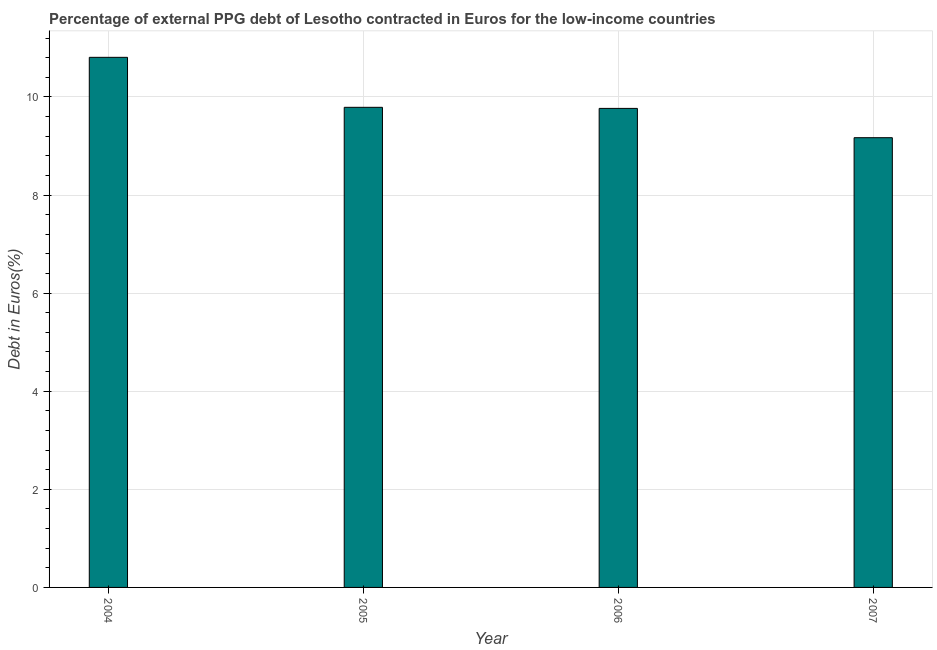Does the graph contain any zero values?
Provide a short and direct response. No. Does the graph contain grids?
Provide a succinct answer. Yes. What is the title of the graph?
Your answer should be very brief. Percentage of external PPG debt of Lesotho contracted in Euros for the low-income countries. What is the label or title of the Y-axis?
Make the answer very short. Debt in Euros(%). What is the currency composition of ppg debt in 2005?
Keep it short and to the point. 9.79. Across all years, what is the maximum currency composition of ppg debt?
Offer a terse response. 10.81. Across all years, what is the minimum currency composition of ppg debt?
Keep it short and to the point. 9.17. In which year was the currency composition of ppg debt minimum?
Ensure brevity in your answer.  2007. What is the sum of the currency composition of ppg debt?
Your answer should be compact. 39.53. What is the average currency composition of ppg debt per year?
Offer a very short reply. 9.88. What is the median currency composition of ppg debt?
Make the answer very short. 9.78. In how many years, is the currency composition of ppg debt greater than 5.2 %?
Offer a terse response. 4. What is the ratio of the currency composition of ppg debt in 2004 to that in 2006?
Keep it short and to the point. 1.11. Is the currency composition of ppg debt in 2006 less than that in 2007?
Make the answer very short. No. Is the sum of the currency composition of ppg debt in 2004 and 2006 greater than the maximum currency composition of ppg debt across all years?
Your answer should be compact. Yes. What is the difference between the highest and the lowest currency composition of ppg debt?
Provide a short and direct response. 1.64. In how many years, is the currency composition of ppg debt greater than the average currency composition of ppg debt taken over all years?
Give a very brief answer. 1. How many bars are there?
Make the answer very short. 4. Are all the bars in the graph horizontal?
Make the answer very short. No. How many years are there in the graph?
Offer a terse response. 4. What is the difference between two consecutive major ticks on the Y-axis?
Your answer should be compact. 2. What is the Debt in Euros(%) of 2004?
Your answer should be very brief. 10.81. What is the Debt in Euros(%) of 2005?
Give a very brief answer. 9.79. What is the Debt in Euros(%) of 2006?
Your answer should be compact. 9.77. What is the Debt in Euros(%) of 2007?
Your answer should be very brief. 9.17. What is the difference between the Debt in Euros(%) in 2004 and 2005?
Ensure brevity in your answer.  1.02. What is the difference between the Debt in Euros(%) in 2004 and 2006?
Your response must be concise. 1.04. What is the difference between the Debt in Euros(%) in 2004 and 2007?
Provide a succinct answer. 1.64. What is the difference between the Debt in Euros(%) in 2005 and 2006?
Provide a short and direct response. 0.02. What is the difference between the Debt in Euros(%) in 2005 and 2007?
Offer a very short reply. 0.62. What is the difference between the Debt in Euros(%) in 2006 and 2007?
Offer a terse response. 0.6. What is the ratio of the Debt in Euros(%) in 2004 to that in 2005?
Your answer should be compact. 1.1. What is the ratio of the Debt in Euros(%) in 2004 to that in 2006?
Provide a succinct answer. 1.11. What is the ratio of the Debt in Euros(%) in 2004 to that in 2007?
Ensure brevity in your answer.  1.18. What is the ratio of the Debt in Euros(%) in 2005 to that in 2007?
Your answer should be compact. 1.07. What is the ratio of the Debt in Euros(%) in 2006 to that in 2007?
Keep it short and to the point. 1.06. 